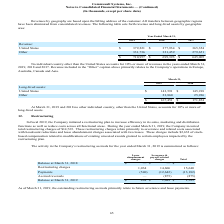From Commvault Systems's financial document, How much was the Restructuring charges related to lease abandonment charges and severance and payroll related charges respectively? The document shows two values: 1,034 and 14,606 (in thousands). From the document: "Restructuring charges 1,034 14,606 15,640 Restructuring charges 1,034 14,606 15,640..." Also, Why did the company initiate a restructuring plan? to increase efficiency in its sales, marketing and distribution functions as well as reduce costs across all functional areas.. The document states: "l 2019, the Company initiated a restructuring plan to increase efficiency in its sales, marketing and distribution functions as well as reduce costs a..." Also, What is the ending balance at March 31, 2019 for Lease abandonment charges and Severance & payroll related charges respectively? The document shows two values: $494 and $1,089 (in thousands). From the document: "Balance at March 31, 2019 $ 494 $ 1,089 $ 1,583 Balance at March 31, 2019 $ 494 $ 1,089 $ 1,583..." Also, can you calculate: What is the net total restructuring charges and payments for Severance & payroll related charges and lease abandonment charges? Based on the calculation: 14,606-12,642+1,034-540, the result is 2458 (in thousands). This is based on the information: "Restructuring charges 1,034 14,606 15,640 Restructuring charges 1,034 14,606 15,640 Payments (540) (12,642) (13,182) Payments (540) (12,642) (13,182)..." The key data points involved are: 1,034, 12,642, 14,606. Also, can you calculate: What fraction of the total restructuring charges included stock-based compensation? Based on the calculation: 2,632/14,765, the result is 0.18. This is based on the information: "Company incurred total restructuring charges of $14,765. These restructuring charges relate primarily to severance and related costs associated with headco ssociated with two leases. These charges inc..." The key data points involved are: 14,765, 2,632. Also, can you calculate: How much more was the balance at march 31, 2019 for Severance & payroll related charges than lease abandonment charges? Based on the calculation: 1,089-494, the result is 595 (in thousands). This is based on the information: "Balance at March 31, 2019 $ 494 $ 1,089 $ 1,583 Balance at March 31, 2019 $ 494 $ 1,089 $ 1,583..." The key data points involved are: 1,089, 494. 